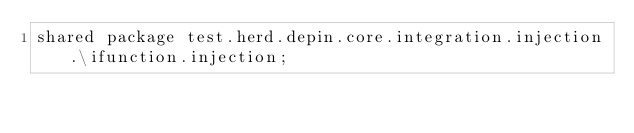<code> <loc_0><loc_0><loc_500><loc_500><_Ceylon_>shared package test.herd.depin.core.integration.injection.\ifunction.injection;
</code> 